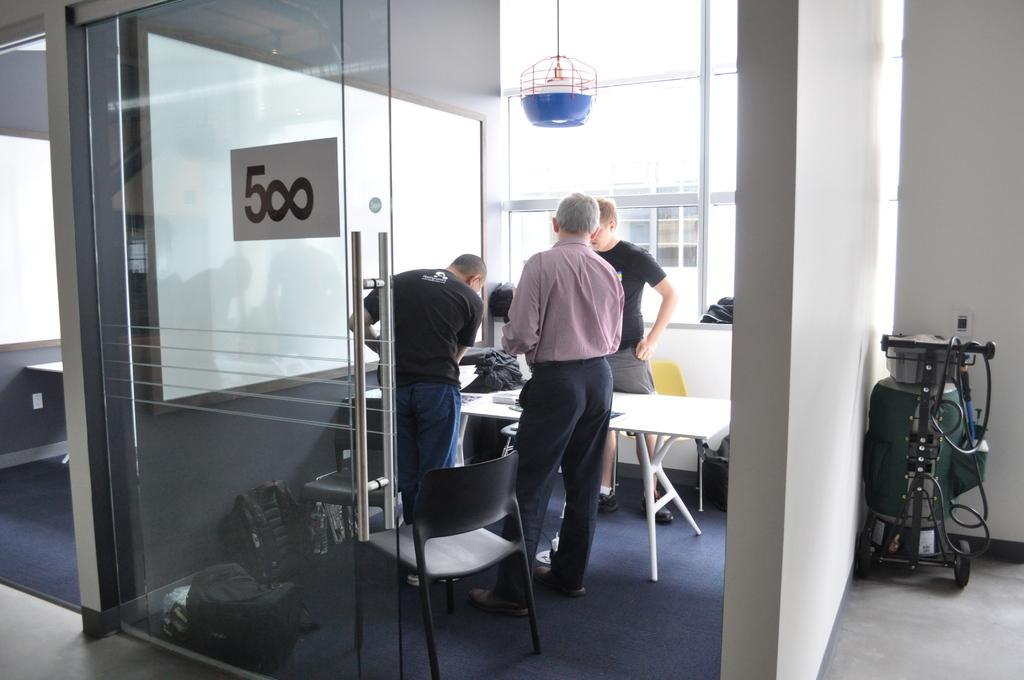<image>
Give a short and clear explanation of the subsequent image. A glass office in a building with the number 500 on it 